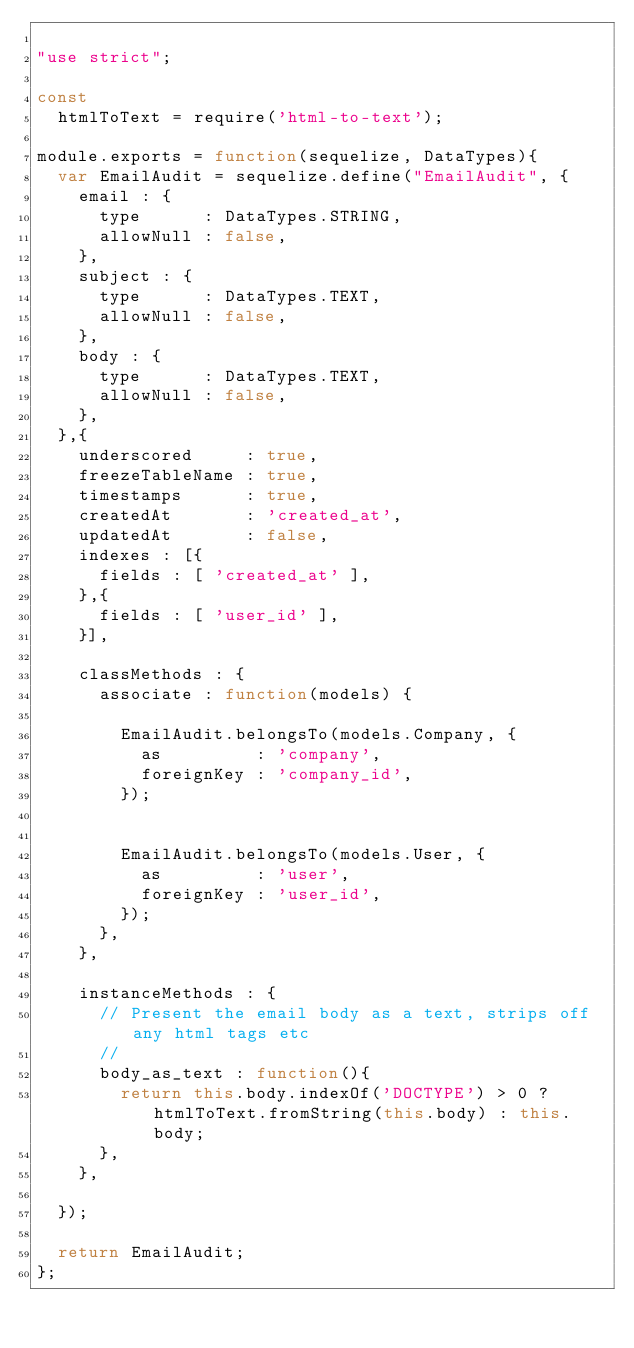<code> <loc_0><loc_0><loc_500><loc_500><_JavaScript_>
"use strict";

const
  htmlToText = require('html-to-text');

module.exports = function(sequelize, DataTypes){
  var EmailAudit = sequelize.define("EmailAudit", {
    email : {
      type      : DataTypes.STRING,
      allowNull : false,
    },
    subject : {
      type      : DataTypes.TEXT,
      allowNull : false,
    },
    body : {
      type      : DataTypes.TEXT,
      allowNull : false,
    },
  },{
    underscored     : true,
    freezeTableName : true,
    timestamps      : true,
    createdAt       : 'created_at',
    updatedAt       : false,
    indexes : [{
      fields : [ 'created_at' ],
    },{
      fields : [ 'user_id' ],
    }],

    classMethods : {
      associate : function(models) {

        EmailAudit.belongsTo(models.Company, {
          as         : 'company',
          foreignKey : 'company_id',
        });


        EmailAudit.belongsTo(models.User, {
          as         : 'user',
          foreignKey : 'user_id',
        });
      },
    },

    instanceMethods : {
      // Present the email body as a text, strips off any html tags etc
      //
      body_as_text : function(){
        return this.body.indexOf('DOCTYPE') > 0 ? htmlToText.fromString(this.body) : this.body;
      },
    },

  });

  return EmailAudit;
};
</code> 